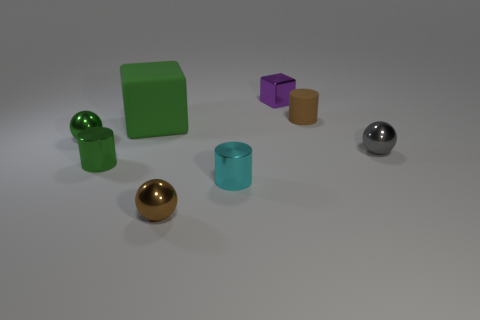Add 1 metal cubes. How many objects exist? 9 Subtract all cylinders. How many objects are left? 5 Subtract all tiny brown rubber cylinders. Subtract all small brown metallic objects. How many objects are left? 6 Add 7 shiny balls. How many shiny balls are left? 10 Add 5 blue matte objects. How many blue matte objects exist? 5 Subtract 0 yellow cylinders. How many objects are left? 8 